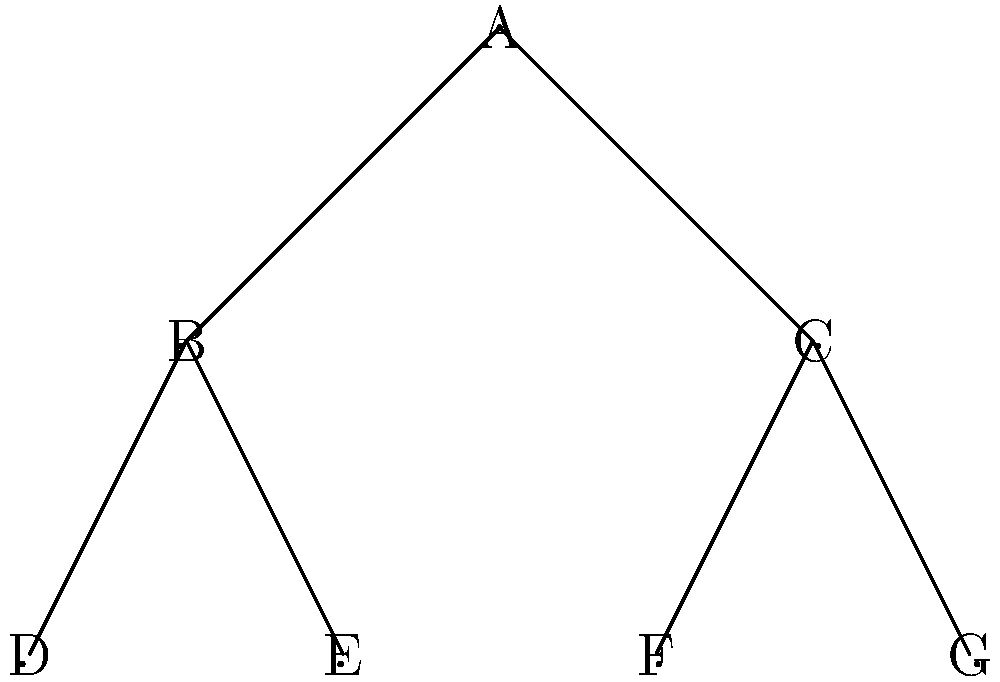As a front-end developer, you're implementing a file system viewer. Given the tree structure above, what would be the correct order of nodes visited in a pre-order traversal? To perform a pre-order traversal of a tree, we follow these steps:

1. Visit the root node
2. Recursively traverse the left subtree
3. Recursively traverse the right subtree

Let's apply this to our tree:

1. Start at the root node A
2. Visit A
3. Move to the left child B
4. Visit B
5. Move to B's left child D
6. Visit D
7. No more children for D, backtrack to B
8. Move to B's right child E
9. Visit E
10. No more children for E, backtrack to B
11. No more children for B, backtrack to A
12. Move to A's right child C
13. Visit C
14. Move to C's left child F
15. Visit F
16. No more children for F, backtrack to C
17. Move to C's right child G
18. Visit G
19. No more children for G, traversal complete

The order in which we visited the nodes is: A, B, D, E, C, F, G
Answer: A, B, D, E, C, F, G 